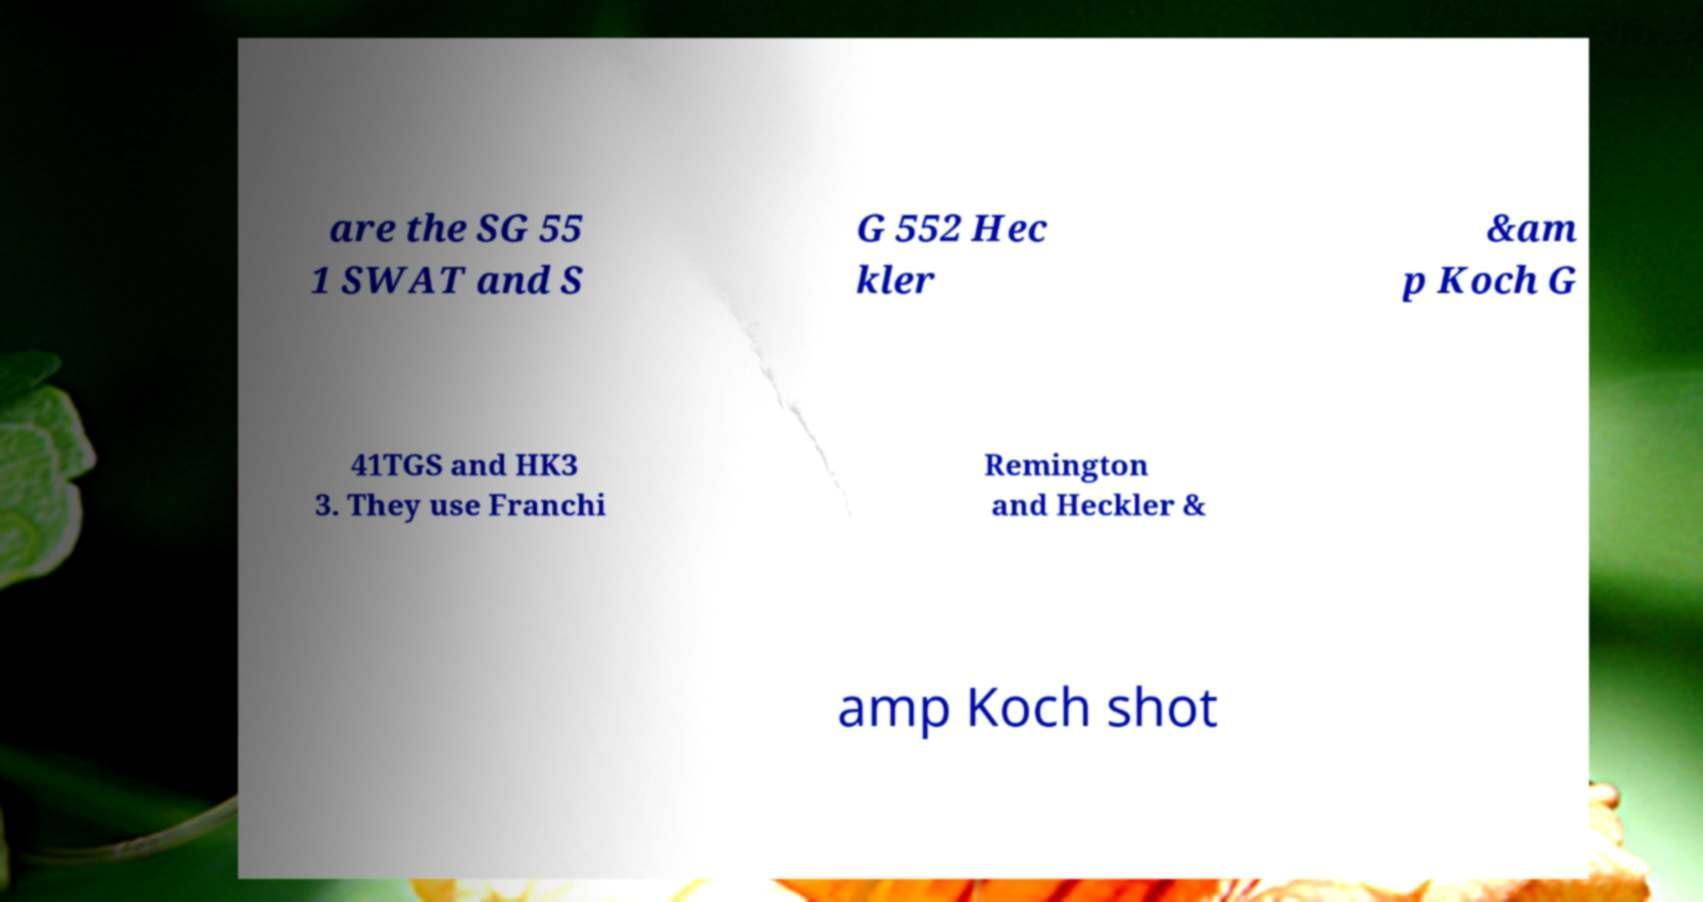Please identify and transcribe the text found in this image. are the SG 55 1 SWAT and S G 552 Hec kler &am p Koch G 41TGS and HK3 3. They use Franchi Remington and Heckler & amp Koch shot 